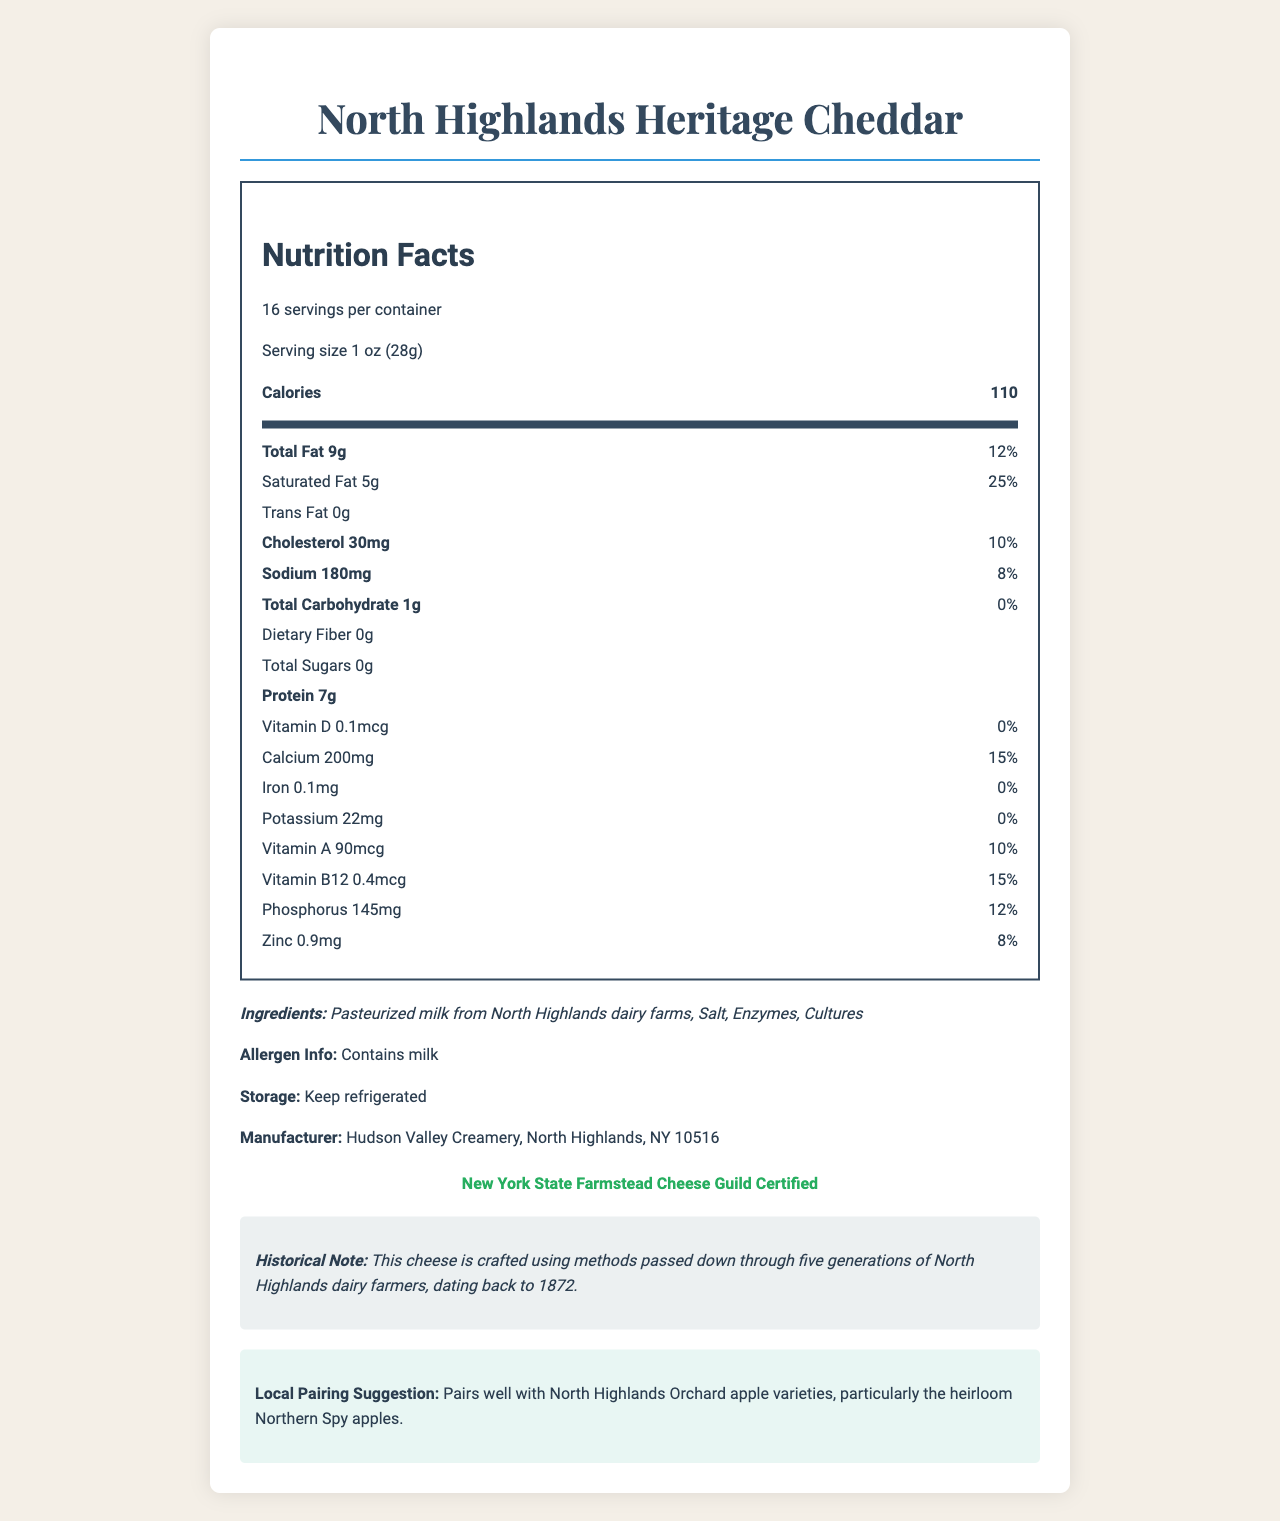what is the serving size? The serving size is clearly stated as "1 oz (28g)" in the document.
Answer: 1 oz (28g) how many servings are in each container? The document specifies that there are 16 servings per container.
Answer: 16 how many calories are in one serving? The document lists the amount of calories per serving as 110.
Answer: 110 what percentage of the daily value of saturated fat does one serving provide? The document indicates that one serving provides 25% of the daily value for saturated fat.
Answer: 25% how much protein does one serving contain? The document states that one serving contains 7 grams of protein.
Answer: 7g what amount of calcium is in one serving? A. 150mg B. 200mg C. 250mg D. 300mg The document states that one serving contains 200mg of calcium.
Answer: B. 200mg what is the primary allergen mentioned in the document? A. Nuts B. Soy C. Milk D. Wheat The document mentions that the product contains milk as an allergen.
Answer: C. Milk is there any dietary fiber in the North Highlands Heritage Cheddar? The document states that it contains 0 grams of dietary fiber.
Answer: No does the product contain any trans fat? The document specifies that the product contains 0 grams of trans fat.
Answer: No describe the historical note included in the document. The historical note highlights that the cheese-making methods have been preserved for five generations, starting from 1872.
Answer: This cheese is crafted using methods passed down through five generations of North Highlands dairy farmers, dating back to 1872. who is the manufacturer of the North Highlands Heritage Cheddar? The document names Hudson Valley Creamery in North Highlands, NY 10516 as the manufacturer.
Answer: Hudson Valley Creamery, North Highlands, NY 10516 what local product does the cheese pair well with? The document suggests that the cheese pairs well with North Highlands Orchard apple varieties, especially the heirloom Northern Spy apples.
Answer: North Highlands Orchard apple varieties, particularly the heirloom Northern Spy apples can the document tell us the price of the North Highlands Heritage Cheddar? The document does not provide any information regarding the price.
Answer: Cannot be determined what vitamin is present in the smallest amount? A. Vitamin D B. Iron C. Potassium D. Zinc Based on the document, Vitamin D is present in the smallest amount, at 0.1mcg per serving.
Answer: A. Vitamin D how should the North Highlands Heritage Cheddar be stored? The storage instructions in the document advise to keep the cheese refrigerated.
Answer: Keep refrigerated does the product provide a significant source of potassium? The document states that there is only 22mg of potassium per serving, and the daily value is 0%, indicating it is not a significant source of potassium.
Answer: No summarize the main features of the North Highlands Heritage Cheddar as shown in the document. The document provides nutrition facts, historical context, storage instructions, pairing suggestions, and certification details for the cheese.
Answer: The North Highlands Heritage Cheddar is an artisanal cheese produced using traditional methods from North Highlands dairy farms, contains 110 calories per serving, and is rich in calcium and protein. The cheese pairs well with local apples and is manufactured by Hudson Valley Creamery. It is certified by the New York State Farmstead Cheese Guild. 